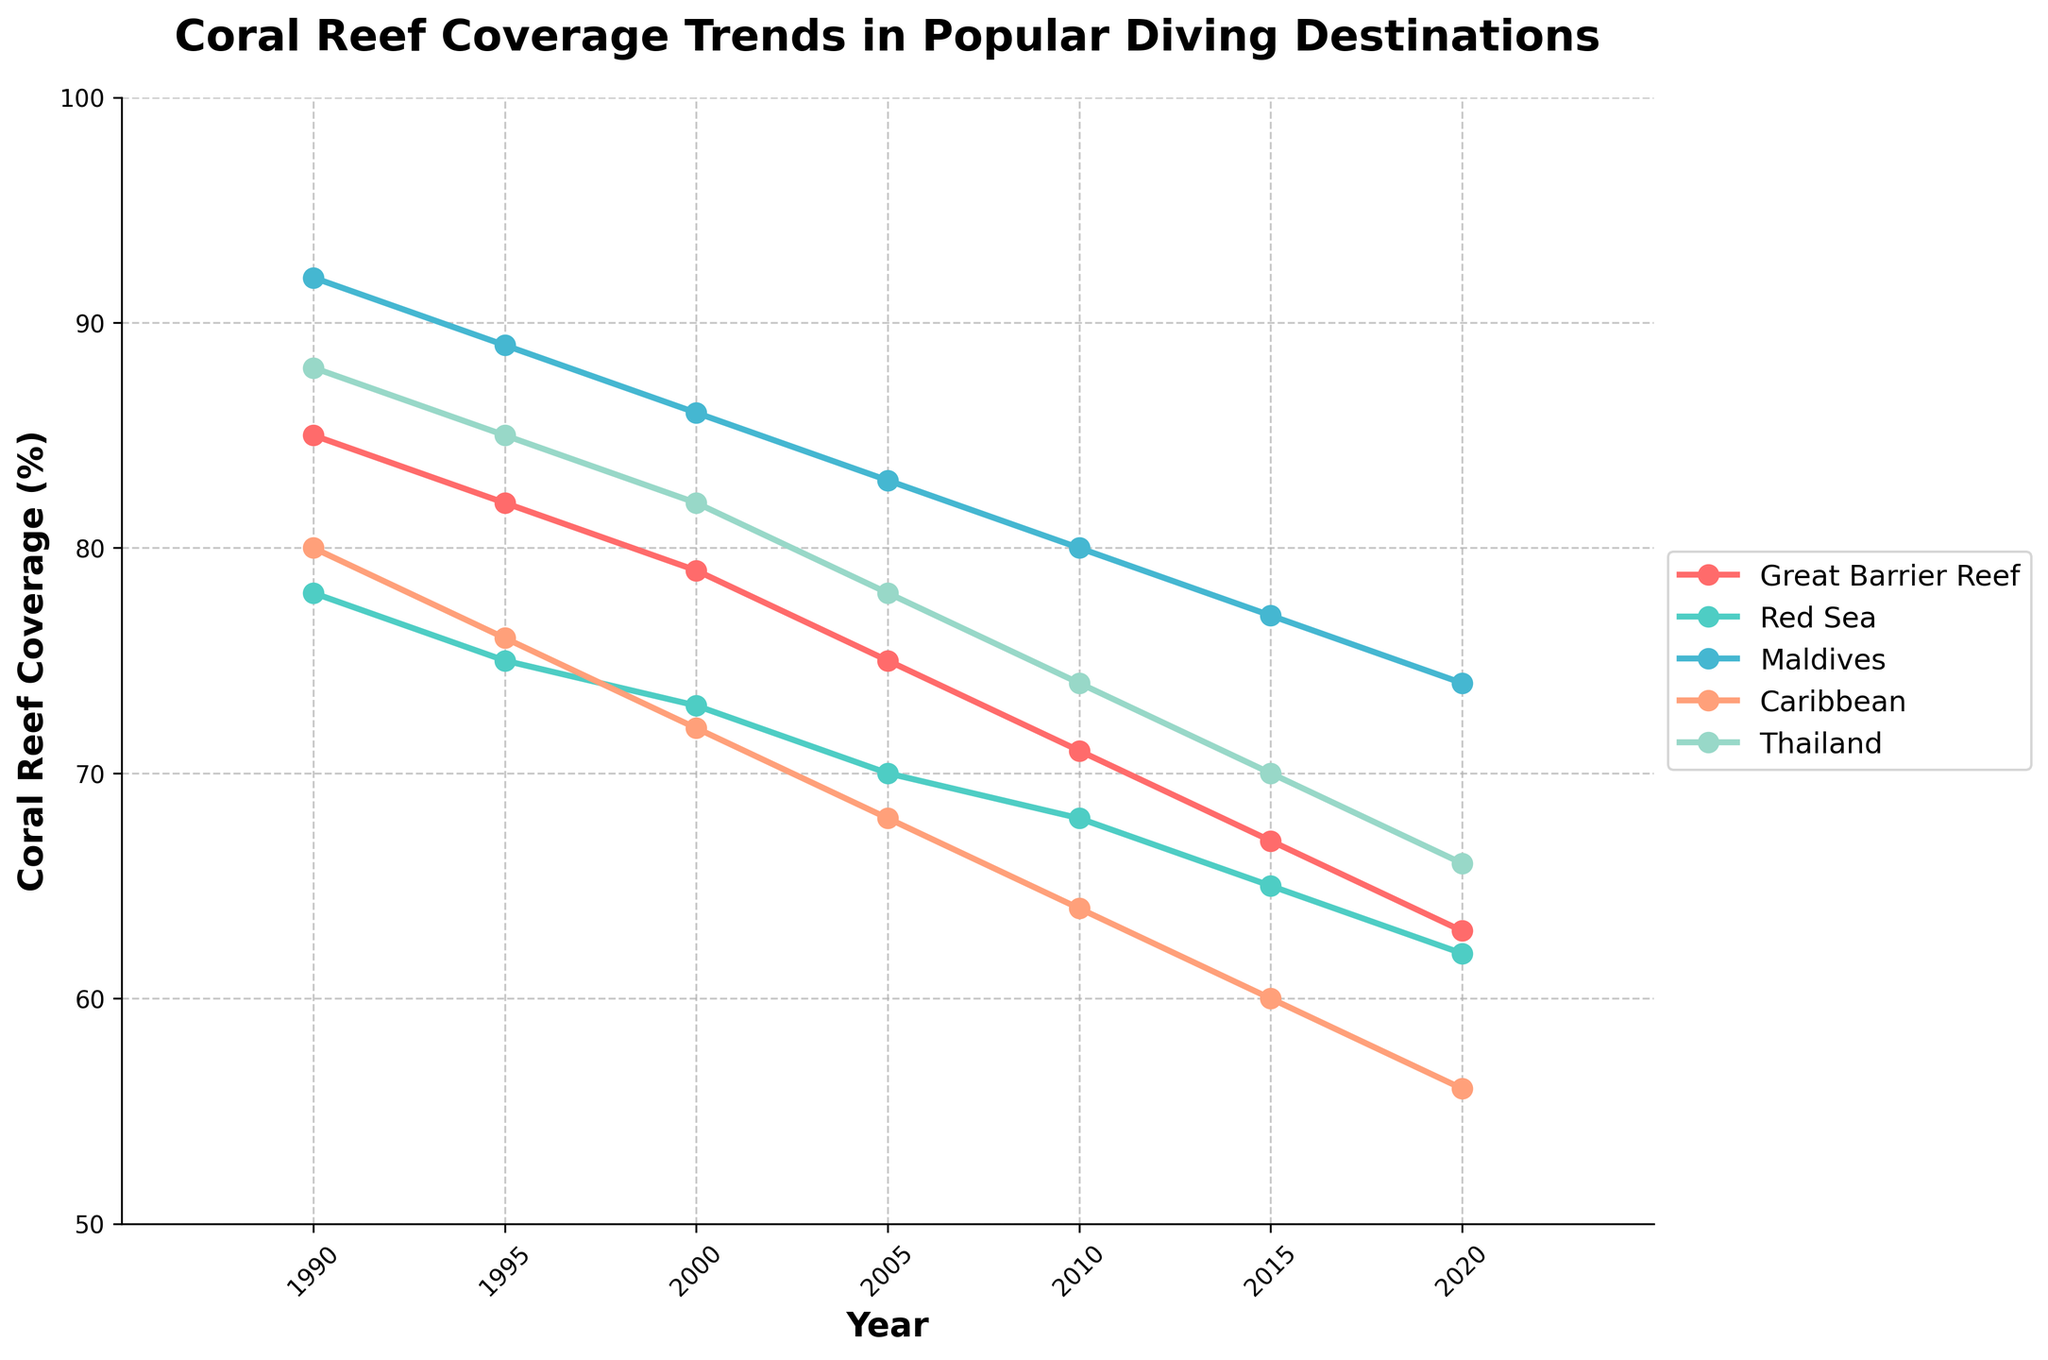What's the average coral reef coverage for the Great Barrier Reef and the Maldives in 2015? To find the average coral reef coverage, sum the values for the Great Barrier Reef (67%) and the Maldives (77%) in 2015, and then divide by the number of destinations (2): (67 + 77) / 2.
Answer: 72% Which destination had the highest coral reef coverage in 1990? By looking at the coral reef coverage values in 1990, the Maldives had the highest value at 92%.
Answer: Maldives How much did the coral reef coverage in the Caribbean decrease from 1990 to 2020? Subtract the coral reef coverage value in 2020 (56%) from the value in 1990 (80%): 80% - 56% = 24%.
Answer: 24% Which two destinations had the closest coral reef coverage values in 2020? Compare the coral reef coverage values in 2020 for all destinations. The Red Sea and Thailand both had values that were quite close, with 62% and 66%, respectively. The difference is 4%.
Answer: Red Sea and Thailand Did any destination maintain a coral reef coverage above 75% in 2010? By checking the coral reef coverage values in 2010, no destination maintained a coverage above 75%. The highest was the Maldives at 80%.
Answer: No Which destination experienced the biggest percentage drop in coral reef coverage from 1990 to 2020? Calculate the percentage drop for each destination from 1990 to 2020 using the formula: (initial value - final value) / initial value * 100. For the Great Barrier Reef: (85 - 63) / 85 * 100 ≈ 25.88%. For the Red Sea: (78 - 62) / 78 * 100 ≈ 20.51%. For the Maldives: (92 - 74) / 92 * 100 ≈ 19.57%. For the Caribbean: (80 - 56) / 80 * 100 = 30%. For Thailand: (88 - 66) / 88 * 100 ≈ 25%. The Caribbean had the largest drop at 30%.
Answer: Caribbean What is the visual trend shown for all destinations from 1990 to 2020? By observing the overall trend of the lines on the chart, all destinations exhibit a general downward trend in coral reef coverage over the 30-year period.
Answer: Downward trend Which destination maintained the highest average coral reef coverage over the entire period? Calculate the average coral reef coverage for each destination over the years provided. Sum each destination's values and divide by the number of data points: Great Barrier Reef: (85+82+79+75+71+67+63)/7 ≈ 74.57%, Red Sea: (78+75+73+70+68+65+62)/7 ≈ 70.14%, Maldives: (92+89+86+83+80+77+74)/7 ≈ 83.00%, Caribbean: (80+76+72+68+64+60+56)/7 ≈ 68.00%, Thailand: (88+85+82+78+74+70+66)/7 ≈ 77.57%. The Maldives had the highest average at 83.00%.
Answer: Maldives What is the difference in coral reef coverage between Thailand and the Red Sea in 2005? Subtract the coral reef coverage value of the Red Sea (70%) from that of Thailand (78%) in 2005: 78% - 70% = 8%.
Answer: 8% 